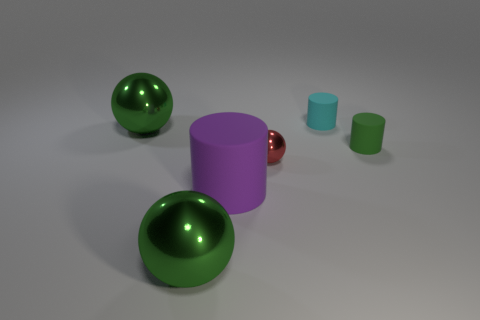There is a big ball behind the green metal ball in front of the large cylinder; what is its color?
Your response must be concise. Green. Is the tiny red metallic object the same shape as the tiny cyan object?
Offer a terse response. No. What is the material of the cyan object that is the same shape as the tiny green object?
Provide a short and direct response. Rubber. Are there any metallic spheres that are left of the large metal ball on the left side of the ball that is in front of the red ball?
Make the answer very short. No. Do the tiny cyan thing and the matte object on the right side of the cyan thing have the same shape?
Provide a succinct answer. Yes. Are there any other things that are the same color as the small shiny sphere?
Keep it short and to the point. No. Do the matte object in front of the red object and the sphere that is behind the green rubber cylinder have the same color?
Your answer should be compact. No. Are there any small cyan rubber blocks?
Your response must be concise. No. Is there a large green thing that has the same material as the cyan cylinder?
Provide a succinct answer. No. Is there any other thing that is made of the same material as the large purple cylinder?
Make the answer very short. Yes. 